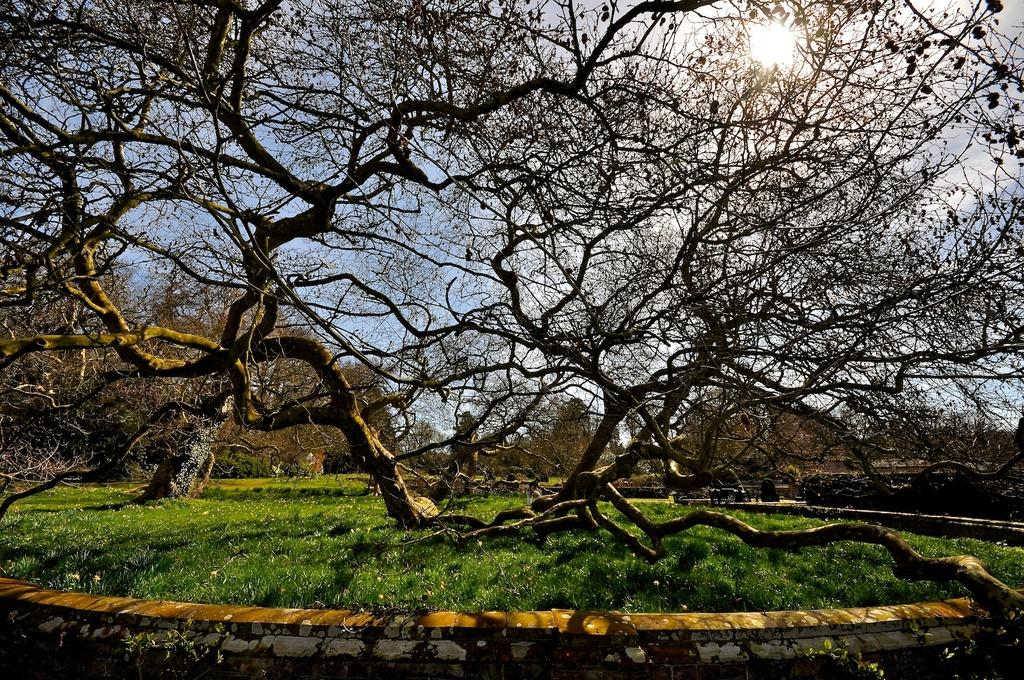What type of vegetation can be seen in the image? There are trees in the image. What is covering the ground in the image? There is grass on the ground in the image. What can be seen in the background of the image? There is a sky visible in the background of the image. What celestial body is observable in the sky? The sun is observable in the sky. What type of bun is being used to hold the railway in the image? There is no bun or railway present in the image. How many slips can be seen on the trees in the image? There are no slips visible on the trees in the image. 